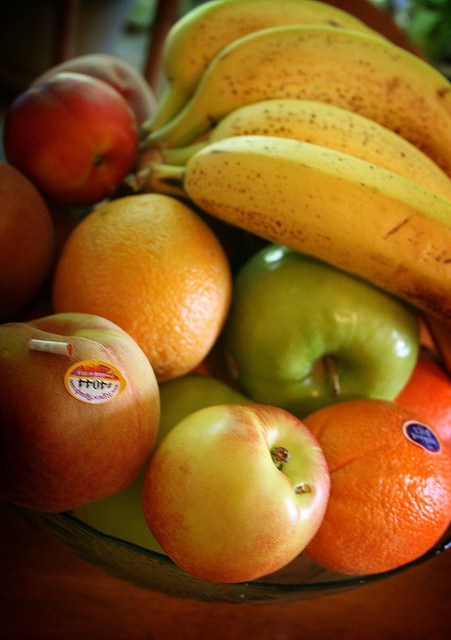Describe the objects in this image and their specific colors. I can see banana in black, orange, olive, and khaki tones, apple in black, maroon, and brown tones, apple in black, olive, tan, and khaki tones, apple in black and olive tones, and bowl in maroon and black tones in this image. 